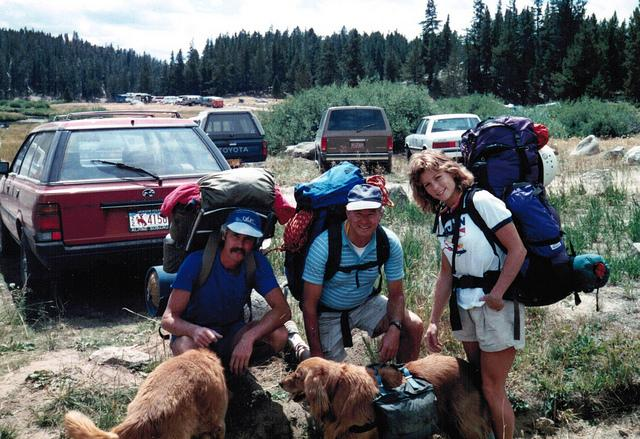What sort of adventure are they probably heading out on?

Choices:
A) flying
B) riding
C) camping
D) swimming camping 